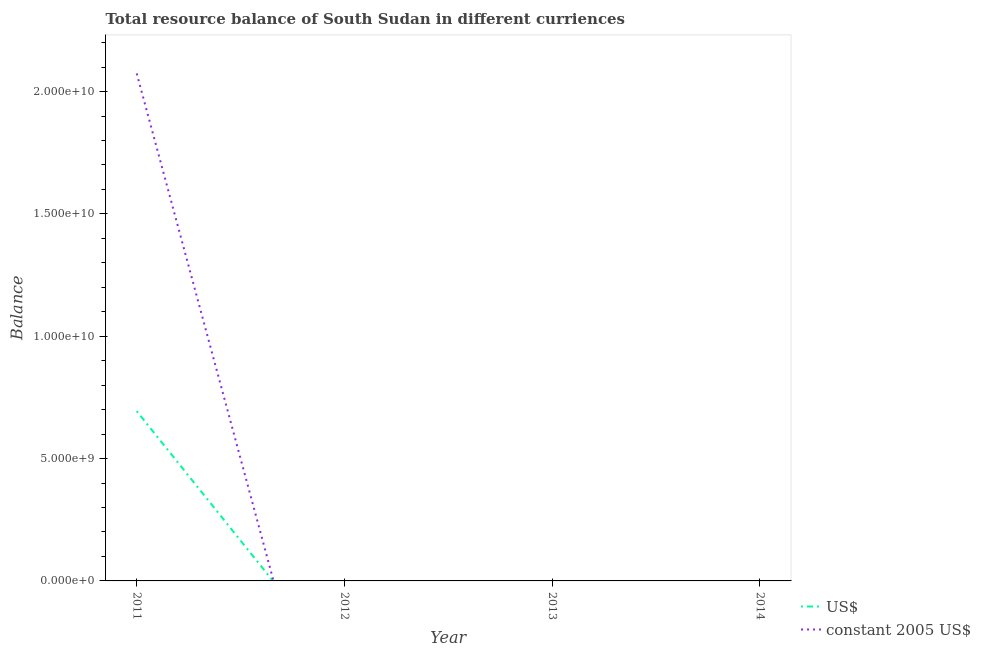What is the resource balance in us$ in 2012?
Your answer should be compact. 0. Across all years, what is the maximum resource balance in us$?
Keep it short and to the point. 6.94e+09. What is the total resource balance in us$ in the graph?
Give a very brief answer. 6.94e+09. What is the difference between the resource balance in us$ in 2011 and the resource balance in constant us$ in 2014?
Keep it short and to the point. 6.94e+09. What is the average resource balance in constant us$ per year?
Keep it short and to the point. 5.19e+09. In the year 2011, what is the difference between the resource balance in constant us$ and resource balance in us$?
Your answer should be very brief. 1.38e+1. What is the difference between the highest and the lowest resource balance in us$?
Ensure brevity in your answer.  6.94e+09. Does the resource balance in us$ monotonically increase over the years?
Provide a short and direct response. No. Is the resource balance in constant us$ strictly greater than the resource balance in us$ over the years?
Offer a very short reply. No. Is the resource balance in constant us$ strictly less than the resource balance in us$ over the years?
Your answer should be compact. No. How many lines are there?
Make the answer very short. 2. How many years are there in the graph?
Give a very brief answer. 4. Are the values on the major ticks of Y-axis written in scientific E-notation?
Provide a short and direct response. Yes. How many legend labels are there?
Keep it short and to the point. 2. How are the legend labels stacked?
Your response must be concise. Vertical. What is the title of the graph?
Give a very brief answer. Total resource balance of South Sudan in different curriences. Does "Under-5(female)" appear as one of the legend labels in the graph?
Your answer should be compact. No. What is the label or title of the X-axis?
Make the answer very short. Year. What is the label or title of the Y-axis?
Keep it short and to the point. Balance. What is the Balance of US$ in 2011?
Offer a very short reply. 6.94e+09. What is the Balance of constant 2005 US$ in 2011?
Offer a terse response. 2.07e+1. What is the Balance of US$ in 2012?
Offer a very short reply. 0. What is the Balance in constant 2005 US$ in 2012?
Provide a succinct answer. 0. What is the Balance of constant 2005 US$ in 2013?
Your answer should be very brief. 0. What is the Balance of constant 2005 US$ in 2014?
Provide a succinct answer. 0. Across all years, what is the maximum Balance of US$?
Your answer should be compact. 6.94e+09. Across all years, what is the maximum Balance in constant 2005 US$?
Offer a very short reply. 2.07e+1. Across all years, what is the minimum Balance in constant 2005 US$?
Offer a terse response. 0. What is the total Balance of US$ in the graph?
Offer a terse response. 6.94e+09. What is the total Balance of constant 2005 US$ in the graph?
Provide a succinct answer. 2.07e+1. What is the average Balance of US$ per year?
Provide a succinct answer. 1.73e+09. What is the average Balance in constant 2005 US$ per year?
Your response must be concise. 5.19e+09. In the year 2011, what is the difference between the Balance in US$ and Balance in constant 2005 US$?
Provide a short and direct response. -1.38e+1. What is the difference between the highest and the lowest Balance in US$?
Offer a terse response. 6.94e+09. What is the difference between the highest and the lowest Balance in constant 2005 US$?
Your answer should be compact. 2.07e+1. 